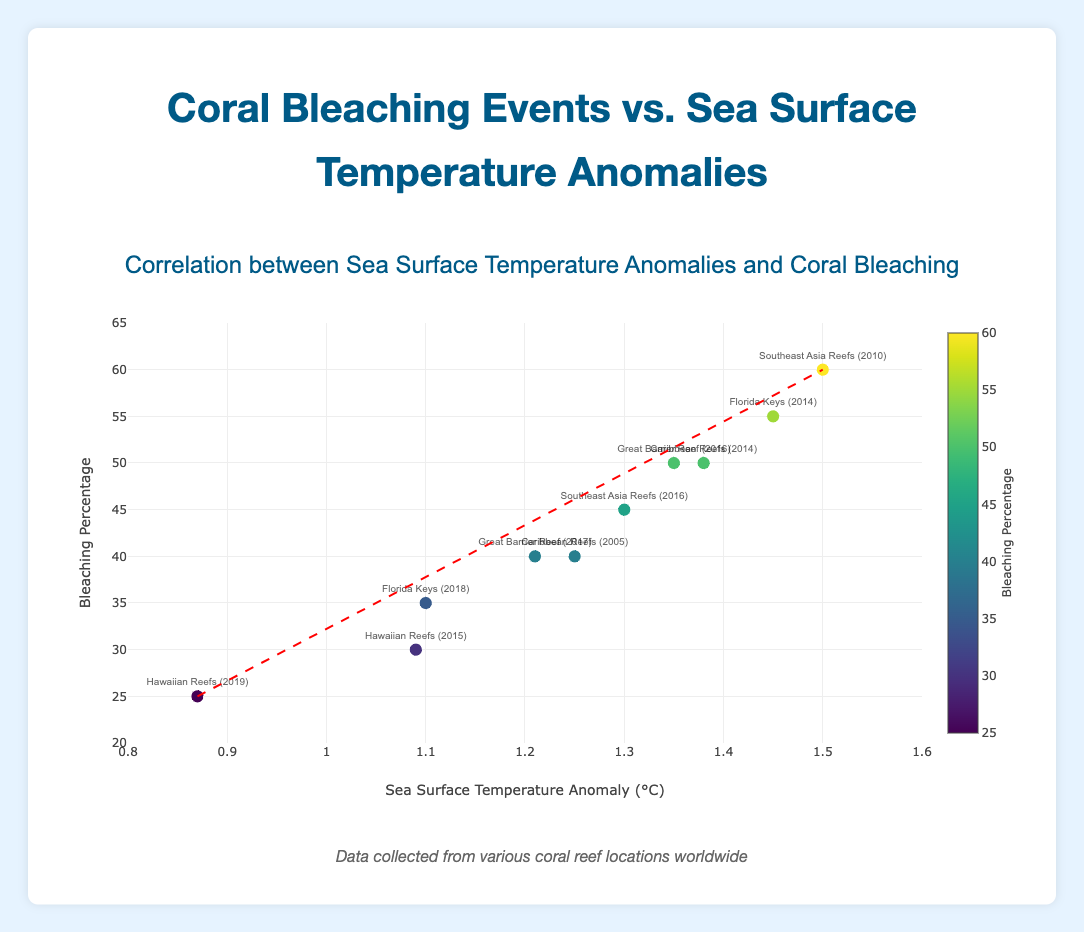What's the title of the figure? The title of the figure is prominently displayed at the top and reads, "Correlation between Sea Surface Temperature Anomalies and Coral Bleaching."
Answer: Correlation between Sea Surface Temperature Anomalies and Coral Bleaching What does the x-axis represent? The x-axis title indicates that it represents "Sea Surface Temperature Anomaly (°C)."
Answer: Sea Surface Temperature Anomaly (°C) How many data points are shown in the figure? By counting the individual markers in the scatter plot, we can see there are 10 data points shown.
Answer: 10 Which reef had the highest bleaching percentage and what was its SST anomaly? By looking at the vertical position of the highest data point, we can see that "Southeast Asia Reefs (2010)" had the highest bleaching percentage of 60% at an SST anomaly of 1.50°C.
Answer: Southeast Asia Reefs (2010), 1.50°C What is the color of the trend line and what type of line is it? The trend line is a dashed red line, as indicated by the visual appearance of the line within the plot.
Answer: Red, dashed What is the difference in bleaching percentage between the "Great Barrier Reef (2016)" and the "Florida Keys (2014)"? The bleaching percentage for "Great Barrier Reef (2016)" is 50%, and for "Florida Keys (2014)" it is 55%. The difference is 55% - 50% = 5%.
Answer: 5% Which year shows the lowest SST anomaly for the "Hawaiian Reefs"? By observing the text labels, the year "2019" shows the lowest SST anomaly for the "Hawaiian Reefs" at 0.87°C.
Answer: 2019 How does the bleaching percentage for "Florida Keys (2014)" compare to "Caribbean Reefs (2014)"? Both "Florida Keys (2014)" and "Caribbean Reefs (2014)" have a bleaching percentage of 50%, making them equal.
Answer: Equal What is the overall trend between sea surface temperature anomalies and coral bleaching percentages? By examining the direction of the trend line, it is observed that there is an upward trend indicating that as sea surface temperature anomalies increase, the percentage of coral bleaching also tends to increase.
Answer: Positive correlation What's the average bleaching percentage across all data points? Summing up all the bleaching percentages (50 + 40 + 30 + 25 + 60 + 45 + 55 + 35 + 40 + 50) gives 430. Dividing by the number of data points (10) results in an average bleaching percentage of 430 / 10 = 43%.
Answer: 43% 